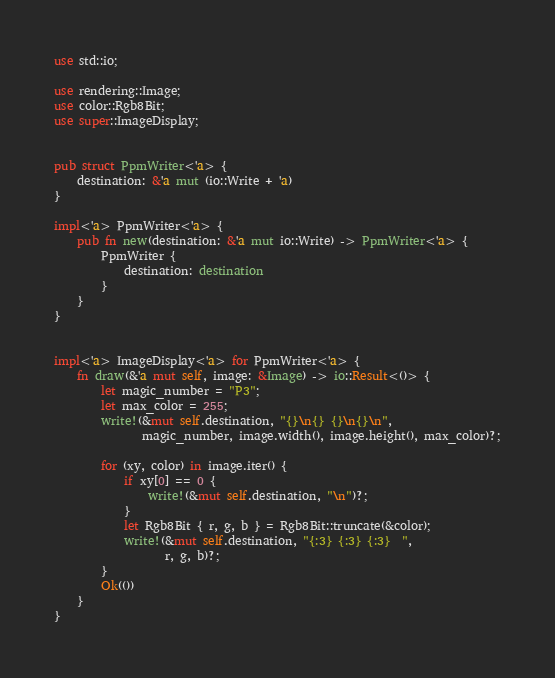<code> <loc_0><loc_0><loc_500><loc_500><_Rust_>use std::io;

use rendering::Image;
use color::Rgb8Bit;
use super::ImageDisplay;


pub struct PpmWriter<'a> {
    destination: &'a mut (io::Write + 'a)
}

impl<'a> PpmWriter<'a> {
    pub fn new(destination: &'a mut io::Write) -> PpmWriter<'a> {
        PpmWriter {
            destination: destination
        }
    }
}


impl<'a> ImageDisplay<'a> for PpmWriter<'a> {
    fn draw(&'a mut self, image: &Image) -> io::Result<()> {
        let magic_number = "P3";
        let max_color = 255;
        write!(&mut self.destination, "{}\n{} {}\n{}\n",
               magic_number, image.width(), image.height(), max_color)?;

        for (xy, color) in image.iter() {
            if xy[0] == 0 {
                write!(&mut self.destination, "\n")?;
            }
            let Rgb8Bit { r, g, b } = Rgb8Bit::truncate(&color);
            write!(&mut self.destination, "{:3} {:3} {:3}  ",
                   r, g, b)?;
        }
        Ok(())
    }
}
</code> 